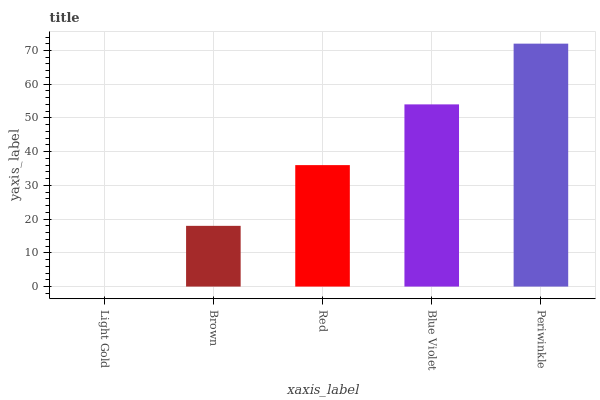Is Light Gold the minimum?
Answer yes or no. Yes. Is Periwinkle the maximum?
Answer yes or no. Yes. Is Brown the minimum?
Answer yes or no. No. Is Brown the maximum?
Answer yes or no. No. Is Brown greater than Light Gold?
Answer yes or no. Yes. Is Light Gold less than Brown?
Answer yes or no. Yes. Is Light Gold greater than Brown?
Answer yes or no. No. Is Brown less than Light Gold?
Answer yes or no. No. Is Red the high median?
Answer yes or no. Yes. Is Red the low median?
Answer yes or no. Yes. Is Brown the high median?
Answer yes or no. No. Is Blue Violet the low median?
Answer yes or no. No. 